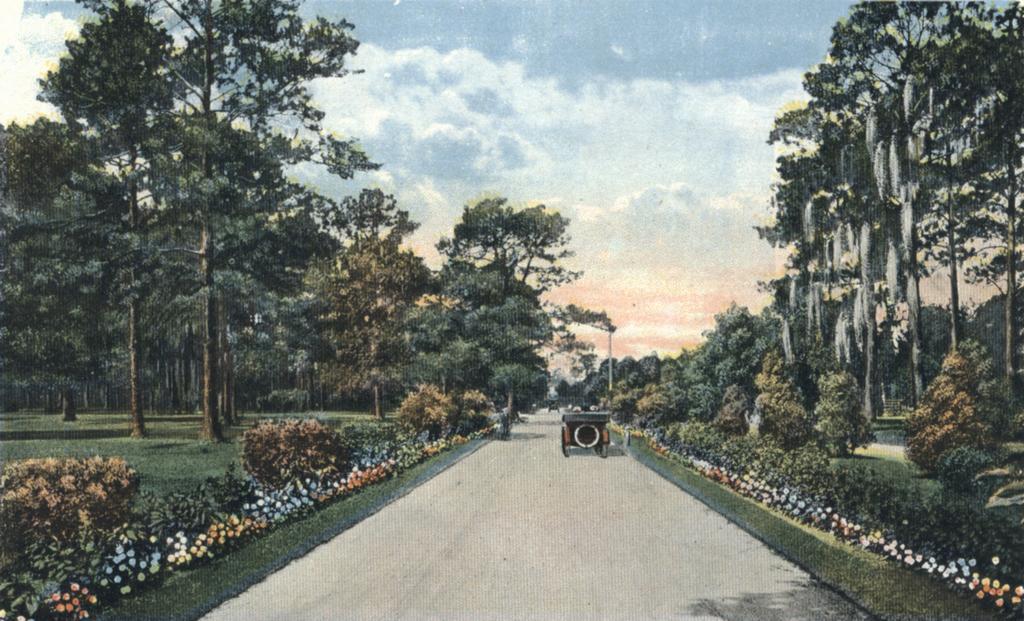How would you summarize this image in a sentence or two? At the top we can see sky with clouds. On either side of the road we can see trees and plants. These are flowers. Here we can see a vehicle on the road. 